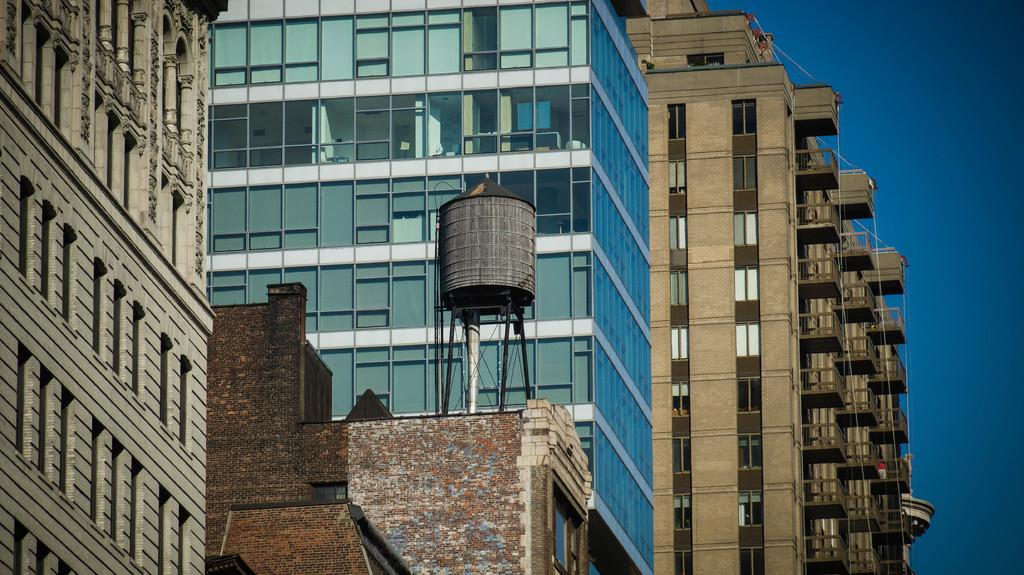What type of structures can be seen in the image? There are buildings in the image. Can you describe any specific features on the buildings? There is a metallic object on one of the buildings. What can be seen in the background of the image? The sky is visible in the image. How does the spy use the hammer to rub the metallic object in the image? There is no spy, hammer, or rubbing action present in the image. The image only shows buildings with a metallic object on one of them and the sky in the background. 